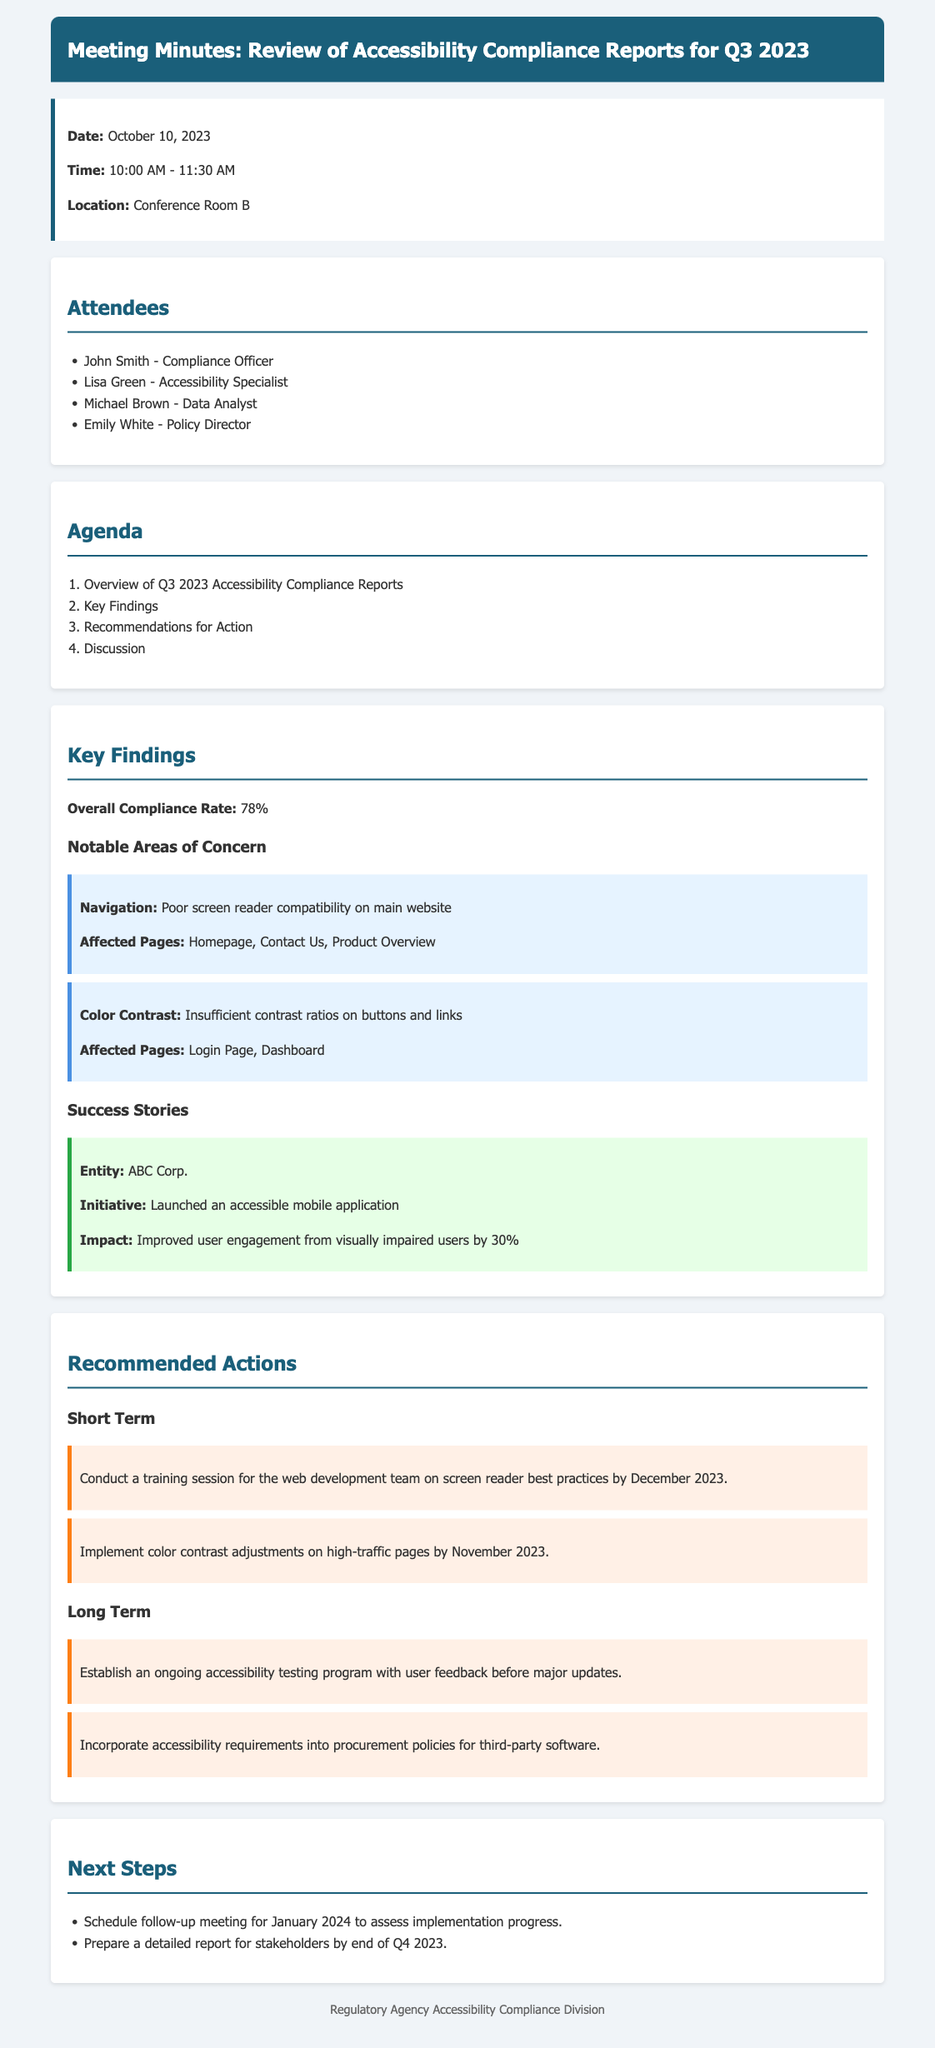what is the overall compliance rate? The overall compliance rate reflects the percentage of compliance determined in the report, which is stated as 78%.
Answer: 78% who conducted the meeting? The meeting was attended by John Smith, who is identified as the Compliance Officer among attendees.
Answer: John Smith when is the follow-up meeting scheduled? The next steps section specifies that a follow-up meeting is scheduled for January 2024.
Answer: January 2024 what is one notable area of concern identified? The key findings mention poor screen reader compatibility as a significant issue that needs attention.
Answer: Poor screen reader compatibility what action is recommended for the web development team? The document outlines a training session focusing on screen reader best practices, recommended for completion by December 2023.
Answer: Conduct a training session which entity launched an accessible mobile application? The success stories section highlights ABC Corp. for its initiative to improve accessibility through a new mobile application.
Answer: ABC Corp what is the deadline for implementing color contrast adjustments? The recommended actions state that color contrast adjustments on high-traffic pages should be completed by November 2023.
Answer: November 2023 what was the impact reported for ABC Corp.'s initiative? The success story notes a significant improvement in user engagement among visually impaired users by 30%.
Answer: Improved user engagement by 30% what should be included in the procurement policies? The recommendations emphasize the incorporation of accessibility requirements into procurement policies for third-party software.
Answer: Accessibility requirements 